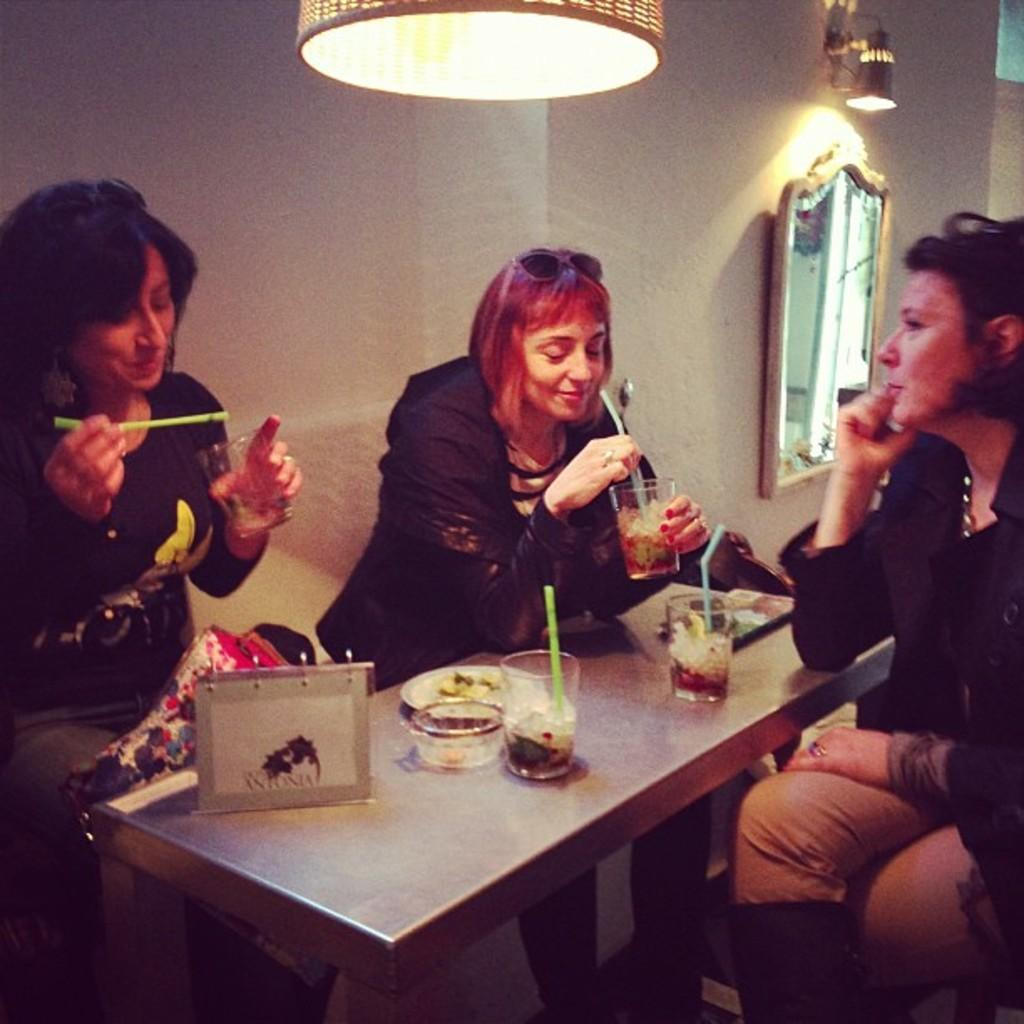How many people are sitting on the table in the image? There are three people sitting on the table in the image. What are the people doing while sitting on the table? The people have food and eatables on top of them, suggesting they are eating. What can be seen in the background of the image? There is a glass mirror and a light fitted to the roof in the background. What type of hook is being used by the governor in the image? There is no governor or hook present in the image. 